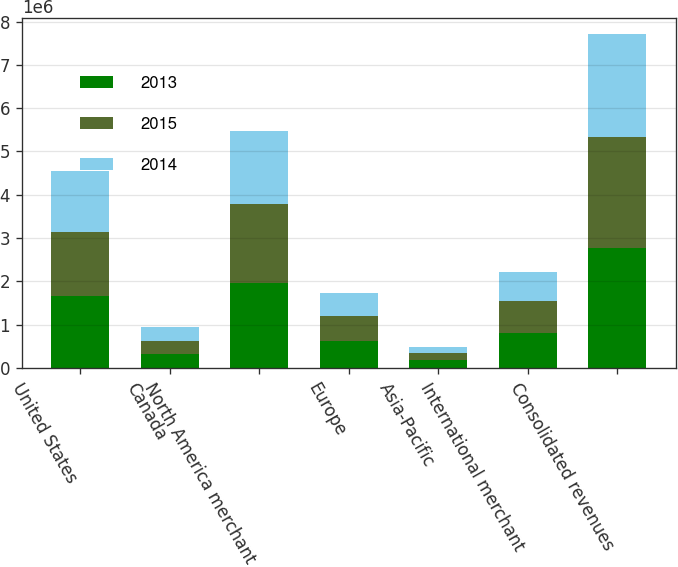Convert chart. <chart><loc_0><loc_0><loc_500><loc_500><stacked_bar_chart><ecel><fcel>United States<fcel>Canada<fcel>North America merchant<fcel>Europe<fcel>Asia-Pacific<fcel>International merchant<fcel>Consolidated revenues<nl><fcel>2013<fcel>1.65587e+06<fcel>313018<fcel>1.96889e+06<fcel>615966<fcel>188862<fcel>804828<fcel>2.77372e+06<nl><fcel>2015<fcel>1.48866e+06<fcel>320333<fcel>1.80899e+06<fcel>587463<fcel>157781<fcel>745244<fcel>2.55424e+06<nl><fcel>2014<fcel>1.39468e+06<fcel>311000<fcel>1.70568e+06<fcel>522593<fcel>147655<fcel>670248<fcel>2.37592e+06<nl></chart> 